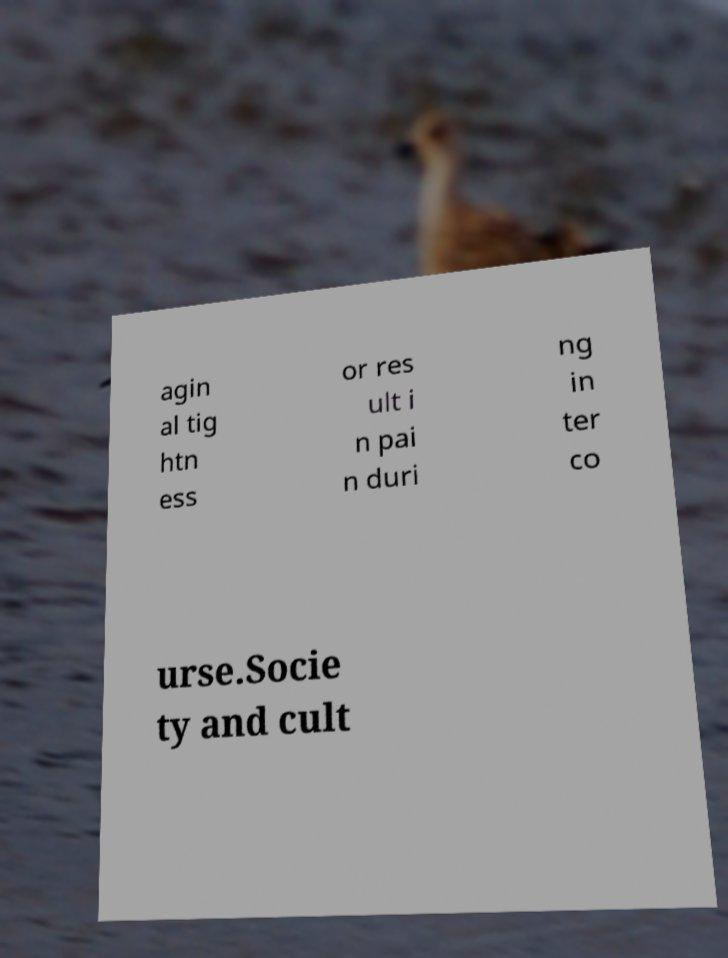There's text embedded in this image that I need extracted. Can you transcribe it verbatim? agin al tig htn ess or res ult i n pai n duri ng in ter co urse.Socie ty and cult 